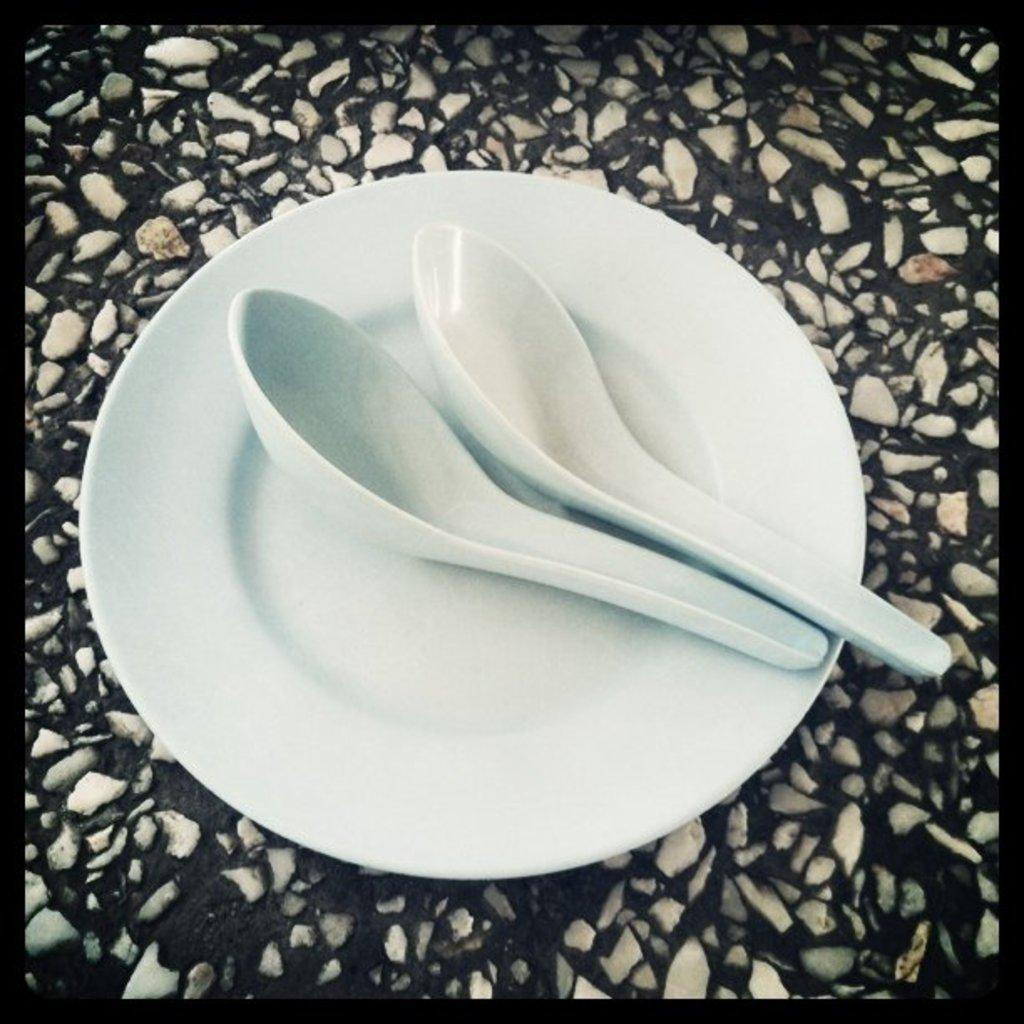What object is present on the plate in the image? There are two spoons on the plate in the image. Can you describe the arrangement of the spoons on the plate? The spoons are placed on the plate, but the specific arrangement is not mentioned in the facts. What direction is the robin flying in the image? There is no robin present in the image, so we cannot determine the direction it might be flying. 